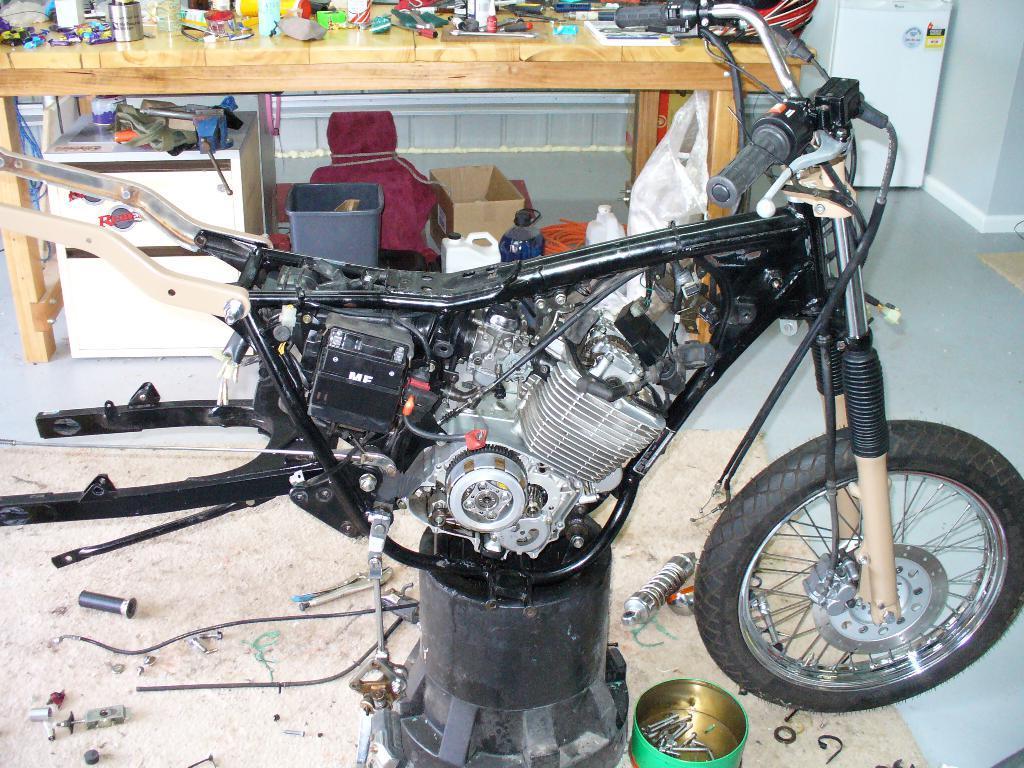In one or two sentences, can you explain what this image depicts? In this image in the center there is bike which is under the repair. In the background there is a table, on the table there are objects, under the table there is a dustbin and there is an object which is red in colour. On the floor there are screws and there are tools. On the right side in the background there is an object which is white in colour. 